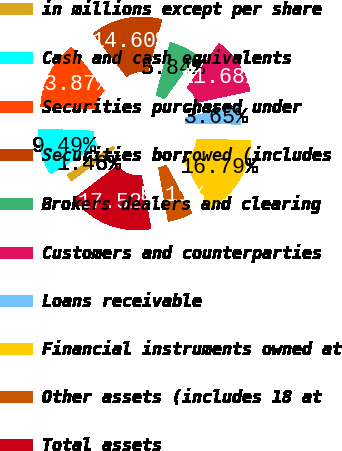Convert chart to OTSL. <chart><loc_0><loc_0><loc_500><loc_500><pie_chart><fcel>in millions except per share<fcel>Cash and cash equivalents<fcel>Securities purchased under<fcel>Securities borrowed (includes<fcel>Brokers dealers and clearing<fcel>Customers and counterparties<fcel>Loans receivable<fcel>Financial instruments owned at<fcel>Other assets (includes 18 at<fcel>Total assets<nl><fcel>1.46%<fcel>9.49%<fcel>13.87%<fcel>14.6%<fcel>5.84%<fcel>11.68%<fcel>3.65%<fcel>16.79%<fcel>5.11%<fcel>17.52%<nl></chart> 